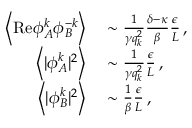<formula> <loc_0><loc_0><loc_500><loc_500>\begin{array} { r l } { \left \langle R e { \phi } _ { A } ^ { k } { \phi } _ { B } ^ { - k } \right \rangle } & \sim \frac { 1 } { \gamma q _ { k } ^ { 2 } } \frac { \delta - \kappa } { \beta } \frac { \epsilon } { L } \, , } \\ { \left \langle | { \phi } _ { A } ^ { k } | ^ { 2 } \right \rangle } & \sim \frac { 1 } { \gamma q _ { k } ^ { 2 } } \frac { \epsilon } { L } \, , } \\ { \left \langle | { \phi } _ { B } ^ { k } | ^ { 2 } \right \rangle } & \sim \frac { 1 } { \beta } \frac { \epsilon } { L } \, , } \end{array}</formula> 